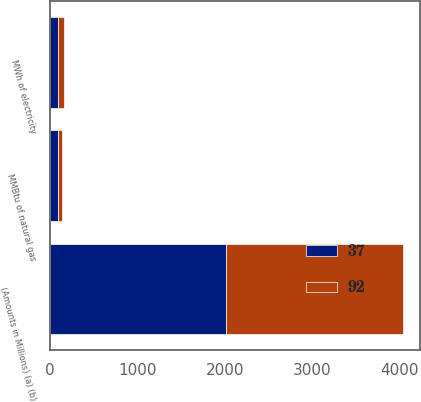<chart> <loc_0><loc_0><loc_500><loc_500><stacked_bar_chart><ecel><fcel>(Amounts in Millions) (a) (b)<fcel>MWh of electricity<fcel>MMBtu of natural gas<nl><fcel>37<fcel>2018<fcel>87<fcel>92<nl><fcel>92<fcel>2017<fcel>68<fcel>37<nl></chart> 